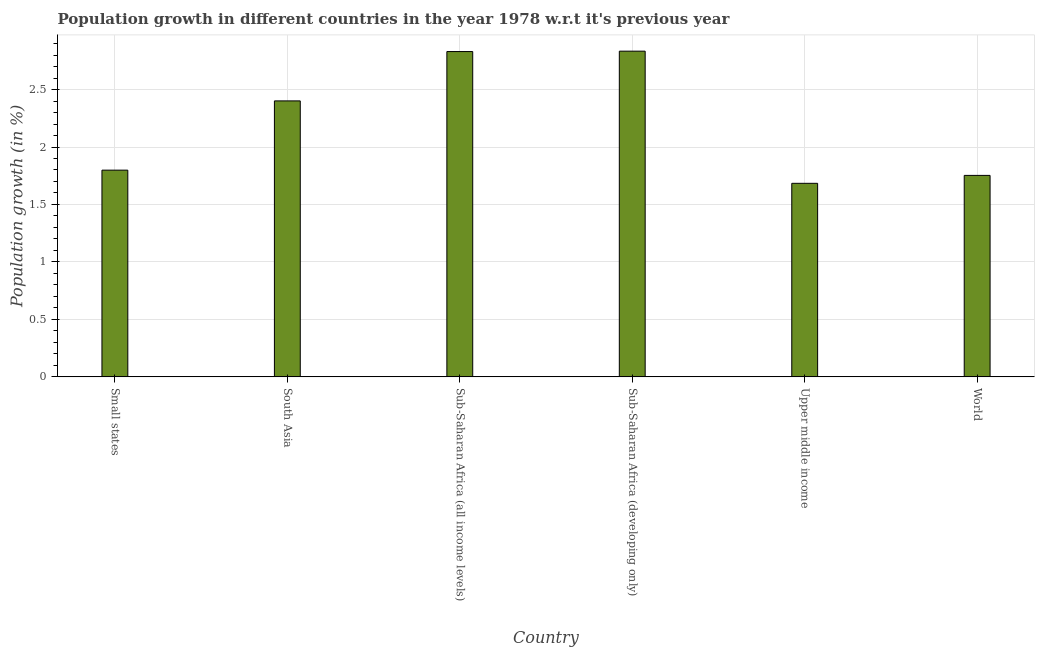Does the graph contain any zero values?
Provide a short and direct response. No. Does the graph contain grids?
Make the answer very short. Yes. What is the title of the graph?
Offer a very short reply. Population growth in different countries in the year 1978 w.r.t it's previous year. What is the label or title of the X-axis?
Make the answer very short. Country. What is the label or title of the Y-axis?
Make the answer very short. Population growth (in %). What is the population growth in Sub-Saharan Africa (all income levels)?
Provide a short and direct response. 2.83. Across all countries, what is the maximum population growth?
Offer a terse response. 2.83. Across all countries, what is the minimum population growth?
Give a very brief answer. 1.68. In which country was the population growth maximum?
Your answer should be very brief. Sub-Saharan Africa (developing only). In which country was the population growth minimum?
Your response must be concise. Upper middle income. What is the sum of the population growth?
Your answer should be compact. 13.3. What is the difference between the population growth in Sub-Saharan Africa (all income levels) and Upper middle income?
Your answer should be very brief. 1.15. What is the average population growth per country?
Keep it short and to the point. 2.22. What is the median population growth?
Offer a terse response. 2.1. What is the ratio of the population growth in Small states to that in Sub-Saharan Africa (all income levels)?
Ensure brevity in your answer.  0.64. Is the population growth in South Asia less than that in Sub-Saharan Africa (developing only)?
Provide a succinct answer. Yes. Is the difference between the population growth in Small states and World greater than the difference between any two countries?
Your answer should be very brief. No. What is the difference between the highest and the second highest population growth?
Give a very brief answer. 0. What is the difference between the highest and the lowest population growth?
Give a very brief answer. 1.15. In how many countries, is the population growth greater than the average population growth taken over all countries?
Give a very brief answer. 3. How many bars are there?
Keep it short and to the point. 6. Are all the bars in the graph horizontal?
Your answer should be compact. No. How many countries are there in the graph?
Keep it short and to the point. 6. Are the values on the major ticks of Y-axis written in scientific E-notation?
Give a very brief answer. No. What is the Population growth (in %) of Small states?
Provide a short and direct response. 1.8. What is the Population growth (in %) of South Asia?
Make the answer very short. 2.4. What is the Population growth (in %) in Sub-Saharan Africa (all income levels)?
Keep it short and to the point. 2.83. What is the Population growth (in %) of Sub-Saharan Africa (developing only)?
Provide a succinct answer. 2.83. What is the Population growth (in %) of Upper middle income?
Offer a terse response. 1.68. What is the Population growth (in %) in World?
Keep it short and to the point. 1.75. What is the difference between the Population growth (in %) in Small states and South Asia?
Keep it short and to the point. -0.6. What is the difference between the Population growth (in %) in Small states and Sub-Saharan Africa (all income levels)?
Your answer should be compact. -1.03. What is the difference between the Population growth (in %) in Small states and Sub-Saharan Africa (developing only)?
Offer a very short reply. -1.04. What is the difference between the Population growth (in %) in Small states and Upper middle income?
Offer a very short reply. 0.11. What is the difference between the Population growth (in %) in Small states and World?
Provide a short and direct response. 0.05. What is the difference between the Population growth (in %) in South Asia and Sub-Saharan Africa (all income levels)?
Give a very brief answer. -0.43. What is the difference between the Population growth (in %) in South Asia and Sub-Saharan Africa (developing only)?
Your response must be concise. -0.43. What is the difference between the Population growth (in %) in South Asia and Upper middle income?
Offer a terse response. 0.72. What is the difference between the Population growth (in %) in South Asia and World?
Give a very brief answer. 0.65. What is the difference between the Population growth (in %) in Sub-Saharan Africa (all income levels) and Sub-Saharan Africa (developing only)?
Your response must be concise. -0. What is the difference between the Population growth (in %) in Sub-Saharan Africa (all income levels) and Upper middle income?
Keep it short and to the point. 1.15. What is the difference between the Population growth (in %) in Sub-Saharan Africa (all income levels) and World?
Give a very brief answer. 1.08. What is the difference between the Population growth (in %) in Sub-Saharan Africa (developing only) and Upper middle income?
Keep it short and to the point. 1.15. What is the difference between the Population growth (in %) in Sub-Saharan Africa (developing only) and World?
Make the answer very short. 1.08. What is the difference between the Population growth (in %) in Upper middle income and World?
Offer a terse response. -0.07. What is the ratio of the Population growth (in %) in Small states to that in South Asia?
Provide a succinct answer. 0.75. What is the ratio of the Population growth (in %) in Small states to that in Sub-Saharan Africa (all income levels)?
Provide a succinct answer. 0.64. What is the ratio of the Population growth (in %) in Small states to that in Sub-Saharan Africa (developing only)?
Keep it short and to the point. 0.64. What is the ratio of the Population growth (in %) in Small states to that in Upper middle income?
Offer a terse response. 1.07. What is the ratio of the Population growth (in %) in South Asia to that in Sub-Saharan Africa (all income levels)?
Provide a short and direct response. 0.85. What is the ratio of the Population growth (in %) in South Asia to that in Sub-Saharan Africa (developing only)?
Your response must be concise. 0.85. What is the ratio of the Population growth (in %) in South Asia to that in Upper middle income?
Ensure brevity in your answer.  1.43. What is the ratio of the Population growth (in %) in South Asia to that in World?
Offer a terse response. 1.37. What is the ratio of the Population growth (in %) in Sub-Saharan Africa (all income levels) to that in Sub-Saharan Africa (developing only)?
Make the answer very short. 1. What is the ratio of the Population growth (in %) in Sub-Saharan Africa (all income levels) to that in Upper middle income?
Offer a very short reply. 1.68. What is the ratio of the Population growth (in %) in Sub-Saharan Africa (all income levels) to that in World?
Provide a succinct answer. 1.61. What is the ratio of the Population growth (in %) in Sub-Saharan Africa (developing only) to that in Upper middle income?
Provide a succinct answer. 1.68. What is the ratio of the Population growth (in %) in Sub-Saharan Africa (developing only) to that in World?
Keep it short and to the point. 1.62. What is the ratio of the Population growth (in %) in Upper middle income to that in World?
Ensure brevity in your answer.  0.96. 